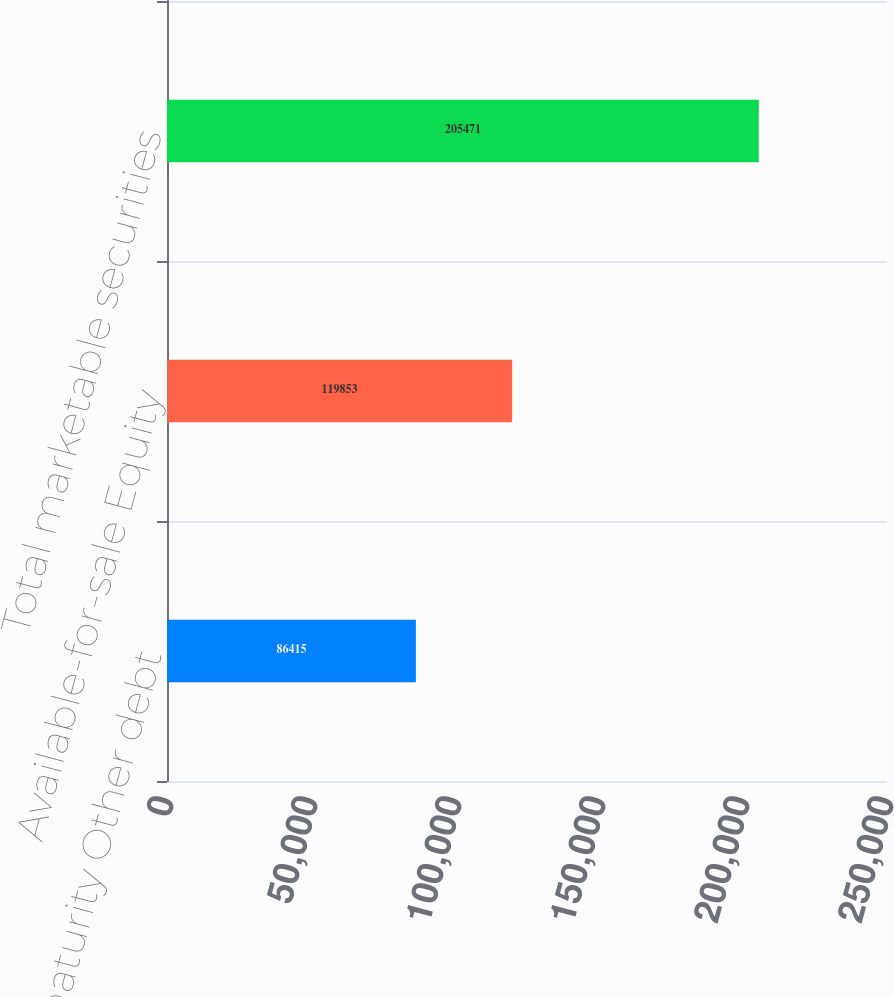Convert chart. <chart><loc_0><loc_0><loc_500><loc_500><bar_chart><fcel>Held-to-maturity Other debt<fcel>Available-for-sale Equity<fcel>Total marketable securities<nl><fcel>86415<fcel>119853<fcel>205471<nl></chart> 